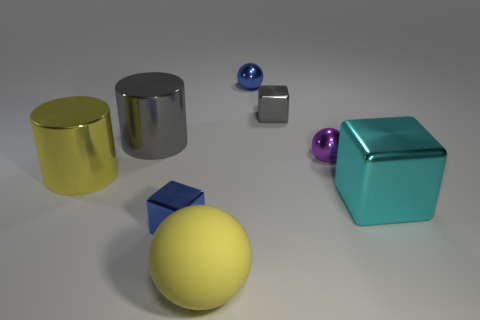Add 1 brown rubber cylinders. How many objects exist? 9 Subtract all cylinders. How many objects are left? 6 Subtract all small metal things. Subtract all tiny purple shiny balls. How many objects are left? 3 Add 5 tiny blue cubes. How many tiny blue cubes are left? 6 Add 6 metallic cylinders. How many metallic cylinders exist? 8 Subtract 0 red spheres. How many objects are left? 8 